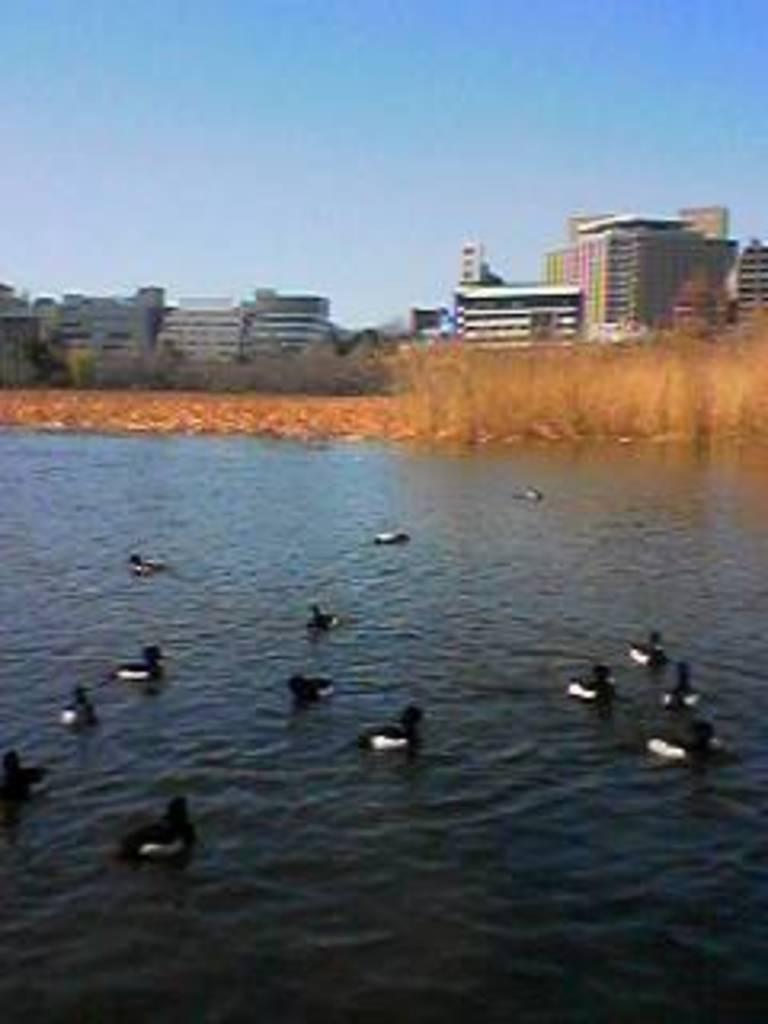Can you describe this image briefly? In this image we can see ducks on the water. In the background there is grass and we can see buildings. At the top there is sky. 